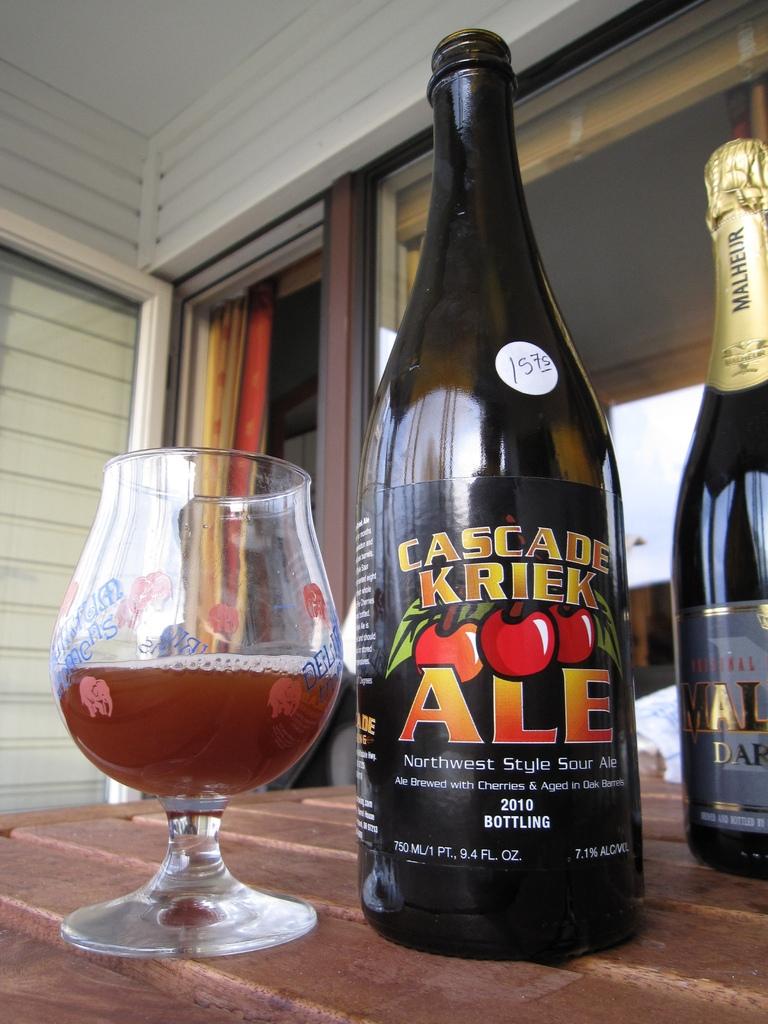What kind of ale is it?
Provide a succinct answer. Cascade kriek. What year is mentioned on the bottle?
Your answer should be compact. 2010. 